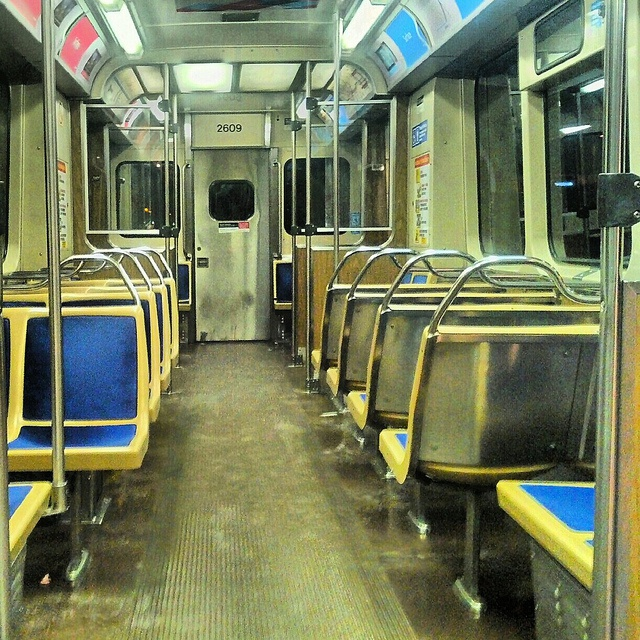Describe the objects in this image and their specific colors. I can see train in olive, black, gray, darkgreen, and darkgray tones, bench in beige, gray, black, olive, and darkgreen tones, chair in beige, black, gray, olive, and darkgreen tones, bench in beige, blue, black, khaki, and navy tones, and chair in beige, gray, khaki, and darkgreen tones in this image. 